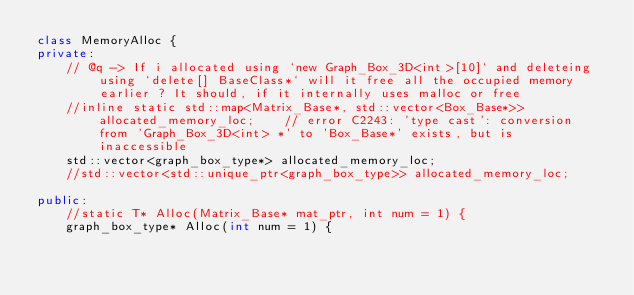Convert code to text. <code><loc_0><loc_0><loc_500><loc_500><_C++_>class MemoryAlloc {
private:
	// @q -> If i allocated using `new Graph_Box_3D<int>[10]` and deleteing using `delete[] BaseClass*` will it free all the occupied memory earlier ? It should, if it internally uses malloc or free
	//inline static std::map<Matrix_Base*, std::vector<Box_Base*>> allocated_memory_loc;	// error C2243: 'type cast': conversion from 'Graph_Box_3D<int> *' to 'Box_Base*' exists, but is inaccessible
	std::vector<graph_box_type*> allocated_memory_loc;
	//std::vector<std::unique_ptr<graph_box_type>> allocated_memory_loc;

public:
	//static T* Alloc(Matrix_Base* mat_ptr, int num = 1) {
	graph_box_type* Alloc(int num = 1) {</code> 